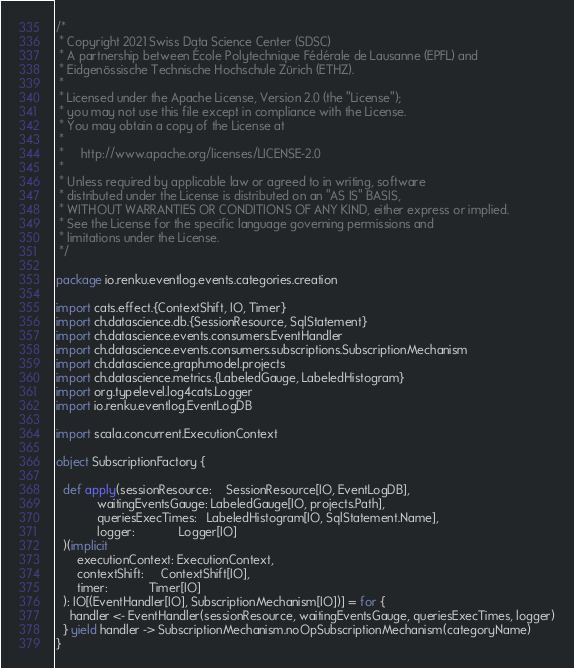<code> <loc_0><loc_0><loc_500><loc_500><_Scala_>/*
 * Copyright 2021 Swiss Data Science Center (SDSC)
 * A partnership between École Polytechnique Fédérale de Lausanne (EPFL) and
 * Eidgenössische Technische Hochschule Zürich (ETHZ).
 *
 * Licensed under the Apache License, Version 2.0 (the "License");
 * you may not use this file except in compliance with the License.
 * You may obtain a copy of the License at
 *
 *     http://www.apache.org/licenses/LICENSE-2.0
 *
 * Unless required by applicable law or agreed to in writing, software
 * distributed under the License is distributed on an "AS IS" BASIS,
 * WITHOUT WARRANTIES OR CONDITIONS OF ANY KIND, either express or implied.
 * See the License for the specific language governing permissions and
 * limitations under the License.
 */

package io.renku.eventlog.events.categories.creation

import cats.effect.{ContextShift, IO, Timer}
import ch.datascience.db.{SessionResource, SqlStatement}
import ch.datascience.events.consumers.EventHandler
import ch.datascience.events.consumers.subscriptions.SubscriptionMechanism
import ch.datascience.graph.model.projects
import ch.datascience.metrics.{LabeledGauge, LabeledHistogram}
import org.typelevel.log4cats.Logger
import io.renku.eventlog.EventLogDB

import scala.concurrent.ExecutionContext

object SubscriptionFactory {

  def apply(sessionResource:    SessionResource[IO, EventLogDB],
            waitingEventsGauge: LabeledGauge[IO, projects.Path],
            queriesExecTimes:   LabeledHistogram[IO, SqlStatement.Name],
            logger:             Logger[IO]
  )(implicit
      executionContext: ExecutionContext,
      contextShift:     ContextShift[IO],
      timer:            Timer[IO]
  ): IO[(EventHandler[IO], SubscriptionMechanism[IO])] = for {
    handler <- EventHandler(sessionResource, waitingEventsGauge, queriesExecTimes, logger)
  } yield handler -> SubscriptionMechanism.noOpSubscriptionMechanism(categoryName)
}
</code> 